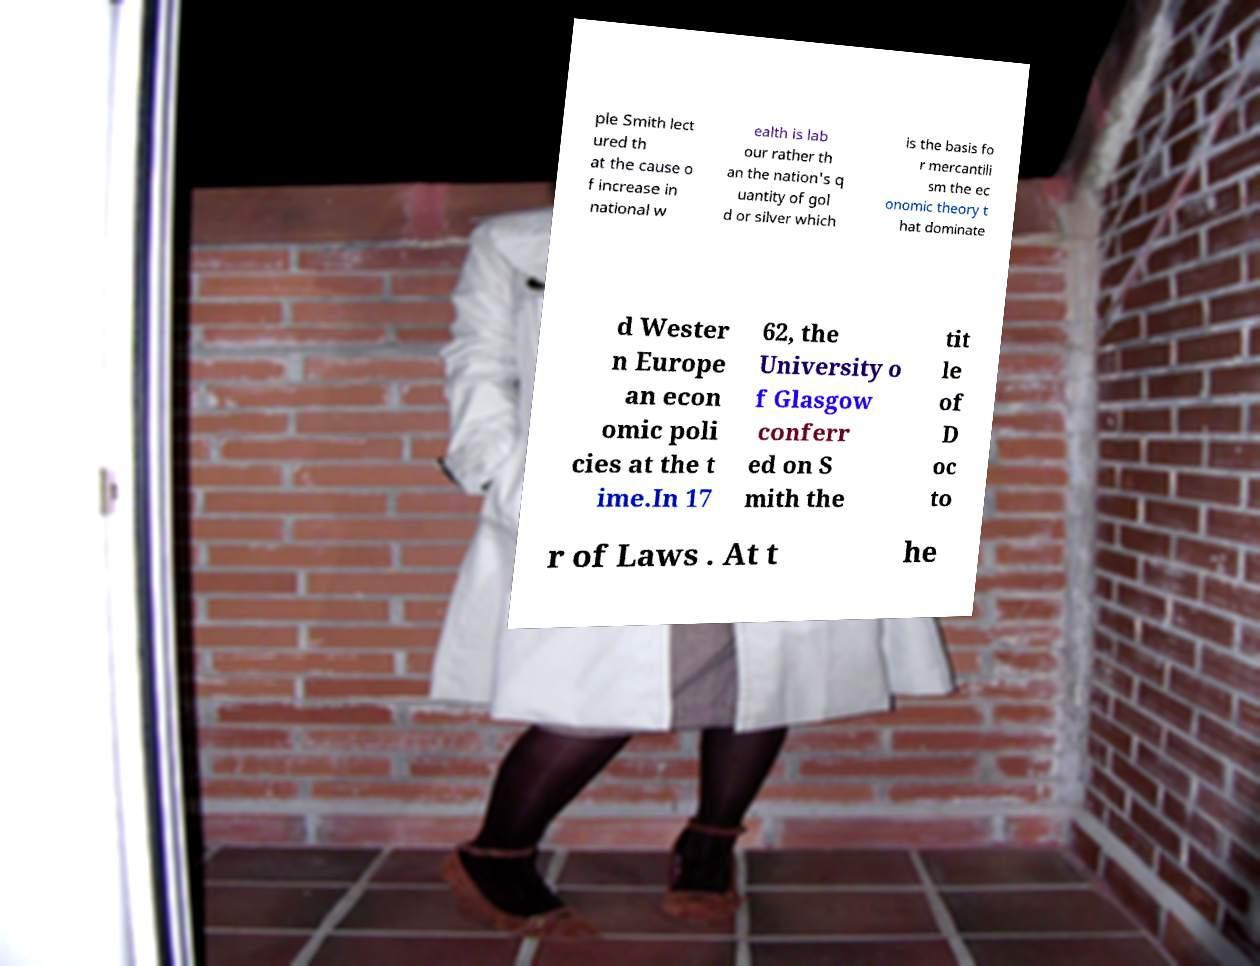For documentation purposes, I need the text within this image transcribed. Could you provide that? ple Smith lect ured th at the cause o f increase in national w ealth is lab our rather th an the nation's q uantity of gol d or silver which is the basis fo r mercantili sm the ec onomic theory t hat dominate d Wester n Europe an econ omic poli cies at the t ime.In 17 62, the University o f Glasgow conferr ed on S mith the tit le of D oc to r of Laws . At t he 